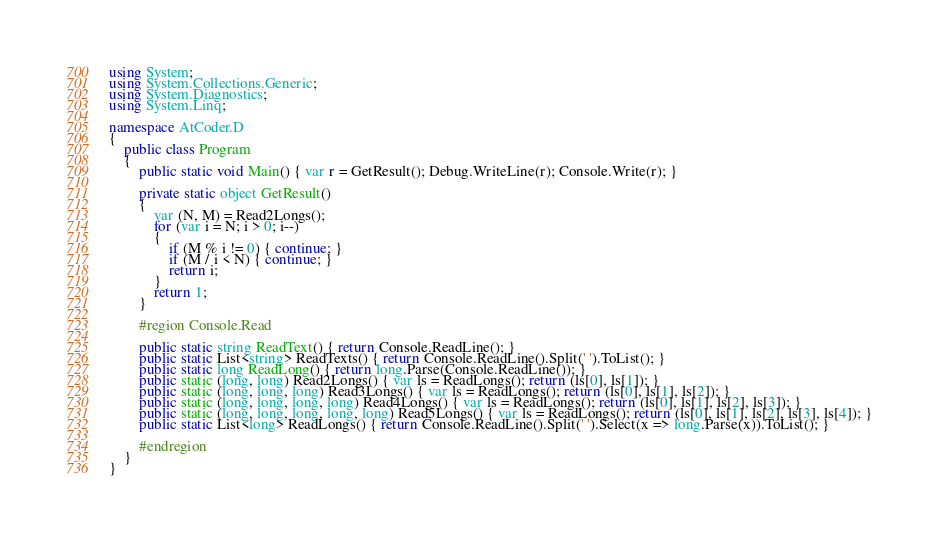<code> <loc_0><loc_0><loc_500><loc_500><_C#_>using System;
using System.Collections.Generic;
using System.Diagnostics;
using System.Linq;

namespace AtCoder.D
{
    public class Program
    {
        public static void Main() { var r = GetResult(); Debug.WriteLine(r); Console.Write(r); }

        private static object GetResult()
        {
            var (N, M) = Read2Longs();
            for (var i = N; i > 0; i--)
            {
                if (M % i != 0) { continue; }
                if (M / i < N) { continue; }
                return i;
            }
            return 1;
        }

        #region Console.Read

        public static string ReadText() { return Console.ReadLine(); }
        public static List<string> ReadTexts() { return Console.ReadLine().Split(' ').ToList(); }
        public static long ReadLong() { return long.Parse(Console.ReadLine()); }
        public static (long, long) Read2Longs() { var ls = ReadLongs(); return (ls[0], ls[1]); }
        public static (long, long, long) Read3Longs() { var ls = ReadLongs(); return (ls[0], ls[1], ls[2]); }
        public static (long, long, long, long) Read4Longs() { var ls = ReadLongs(); return (ls[0], ls[1], ls[2], ls[3]); }
        public static (long, long, long, long, long) Read5Longs() { var ls = ReadLongs(); return (ls[0], ls[1], ls[2], ls[3], ls[4]); }
        public static List<long> ReadLongs() { return Console.ReadLine().Split(' ').Select(x => long.Parse(x)).ToList(); }

        #endregion
    }
}
</code> 